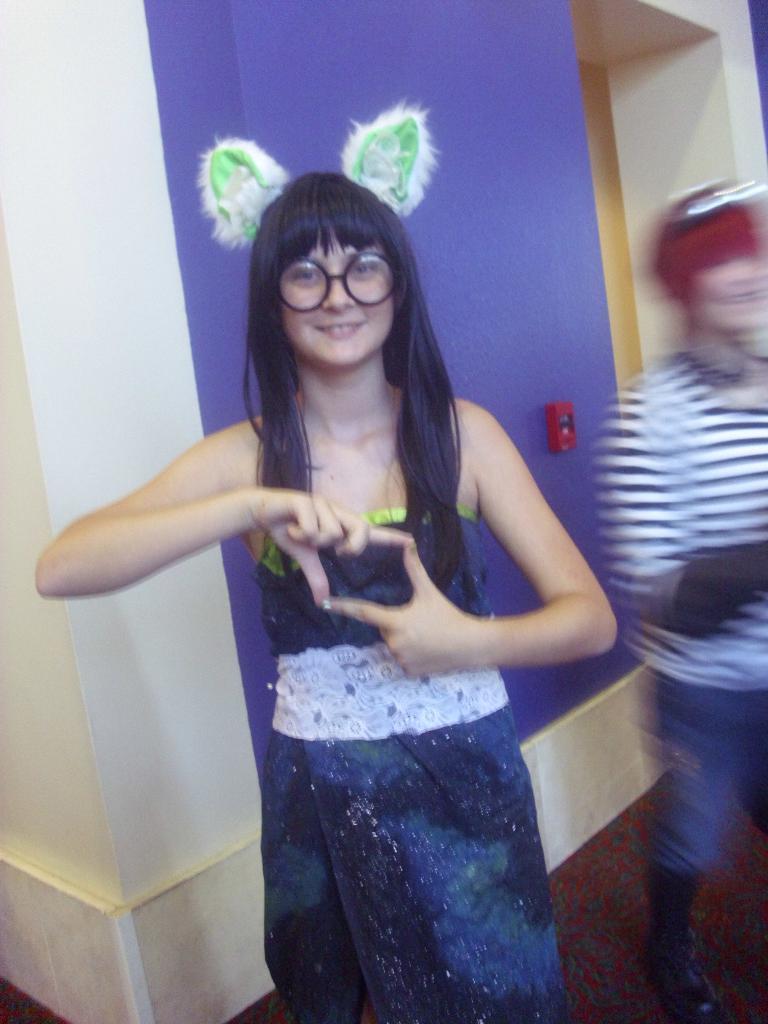How would you summarize this image in a sentence or two? In this image we can see persons standing on the floor. In the background we can see power notch and walls. 